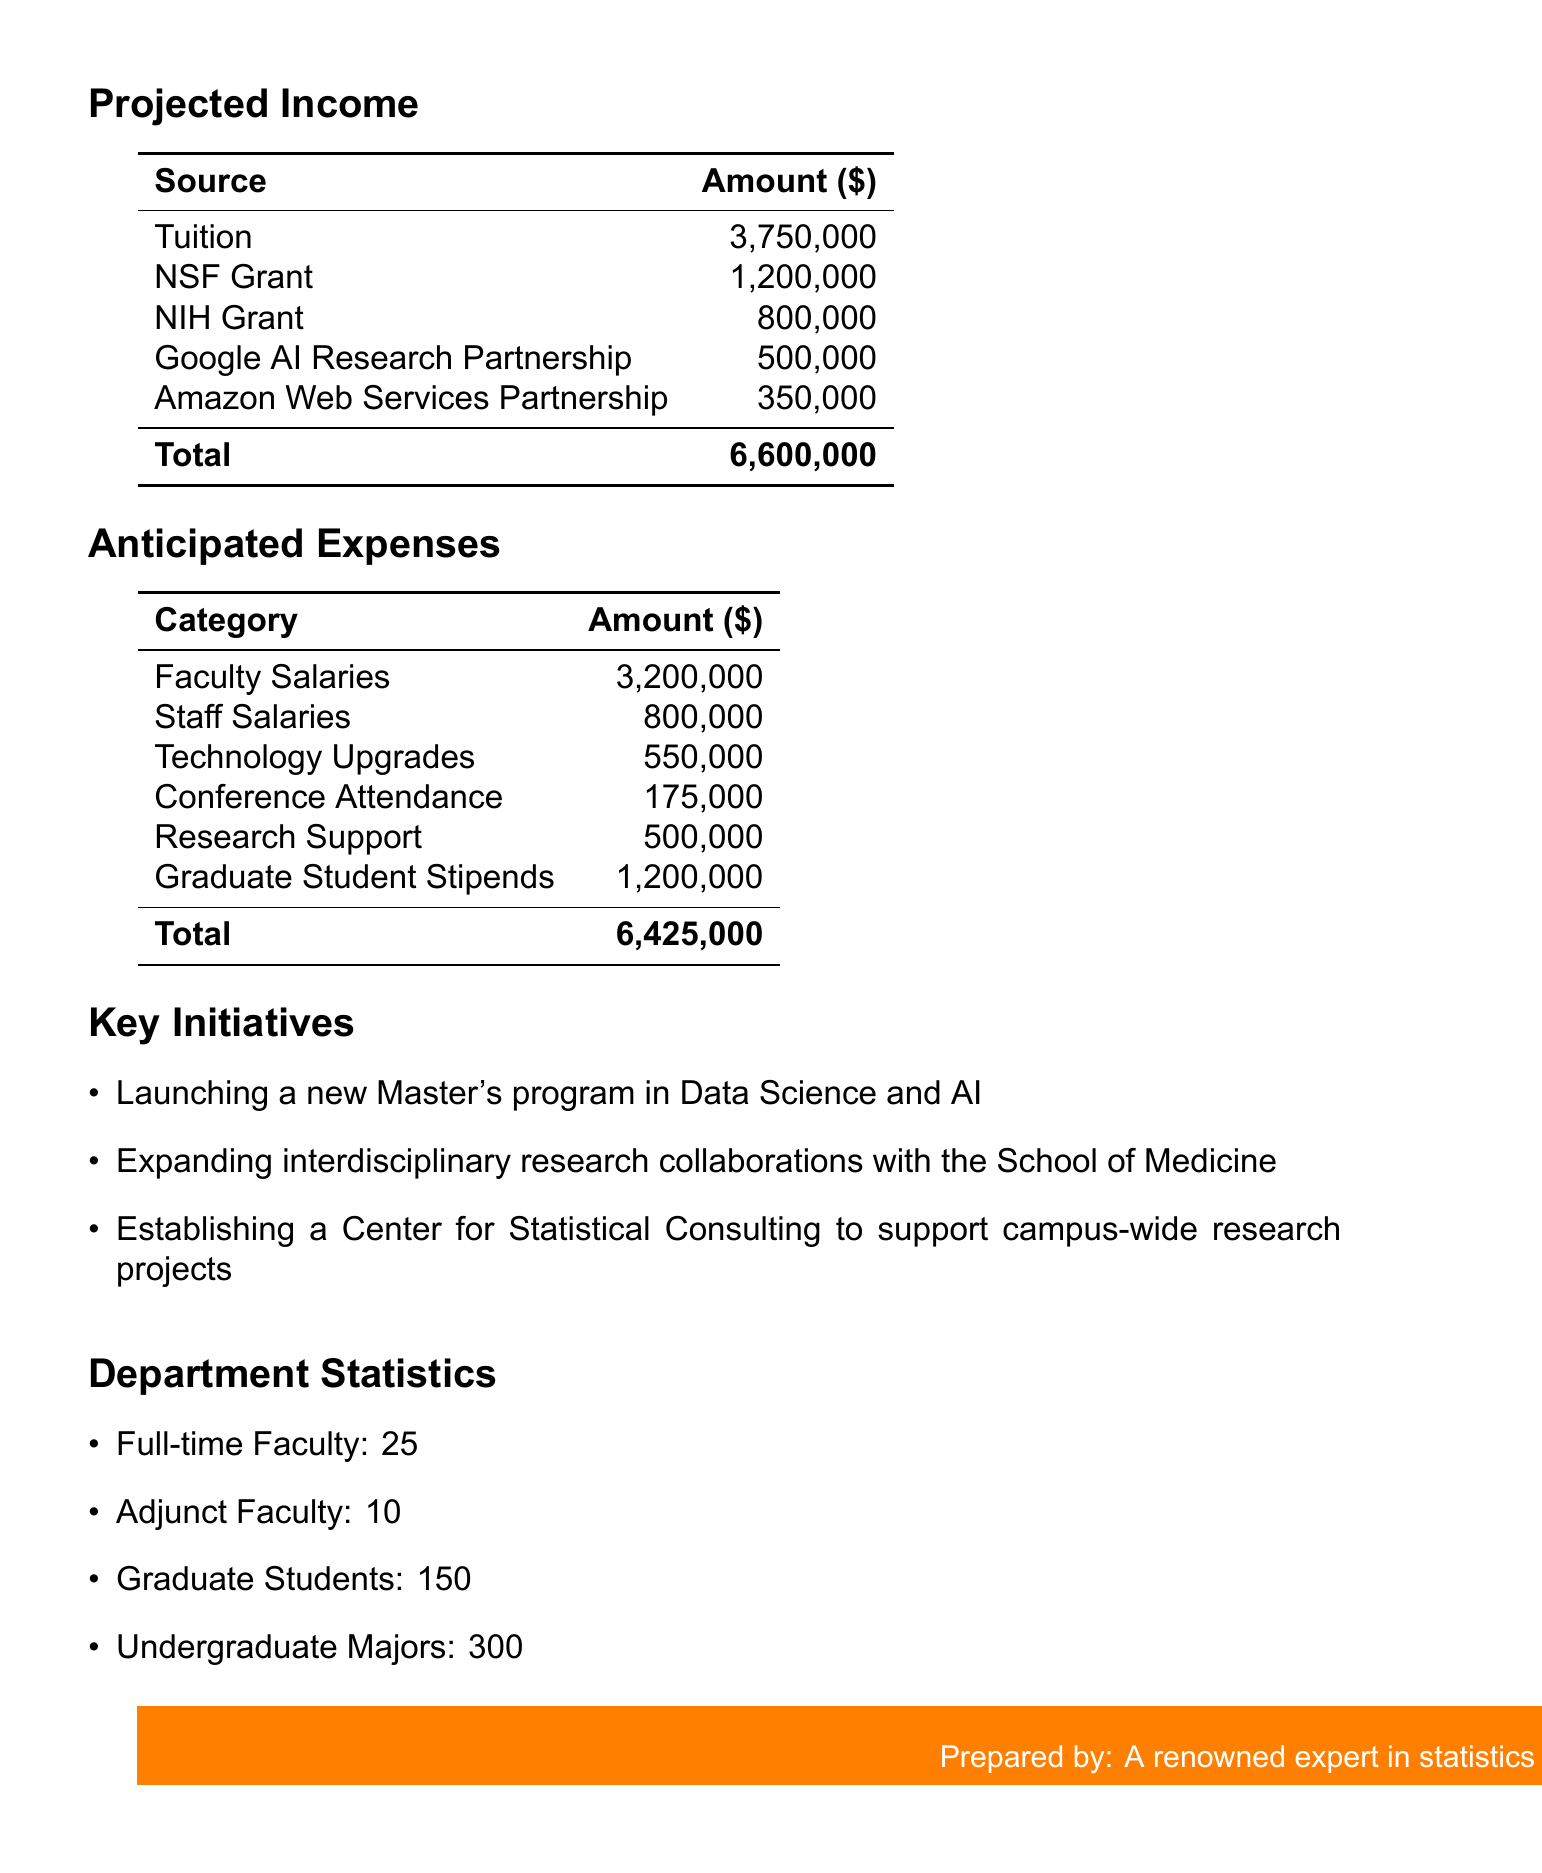What is the projected income from tuition? The projected income from tuition is explicitly stated in the document, which is $3,750,000.
Answer: $3,750,000 What is the total amount of research grants? The total amount of research grants is the sum of the NSF and NIH grants provided in the document, which is $1,200,000 + $800,000 = $2,000,000.
Answer: $2,000,000 What is the budget for technology upgrades? The budget for technology upgrades includes the amounts specified for the high-performance computing cluster and the data visualization lab, totaling $400,000 + $150,000 = $550,000.
Answer: $550,000 What is the anticipated expense for faculty salaries? The anticipated expense for faculty salaries is clearly stated in the document, which is $3,200,000.
Answer: $3,200,000 How many full-time faculty members are there? The document lists the number of full-time faculty members explicitly, which is 25.
Answer: 25 What is the total amount of anticipated expenses? The total amount of anticipated expenses is the sum of all categories listed, equal to $6,425,000.
Answer: $6,425,000 What key initiative involves the School of Medicine? The key initiative that mentions the School of Medicine is expanding interdisciplinary research collaborations.
Answer: Expanding interdisciplinary research collaborations with the School of Medicine What is the amount received from the Google AI Research partnership? The specific amount received from the Google AI Research partnership is mentioned in the document as $500,000.
Answer: $500,000 What is the budget for conference attendance? The budget for conference attendance includes the total from the various conferences mentioned, which adds up to $175,000.
Answer: $175,000 